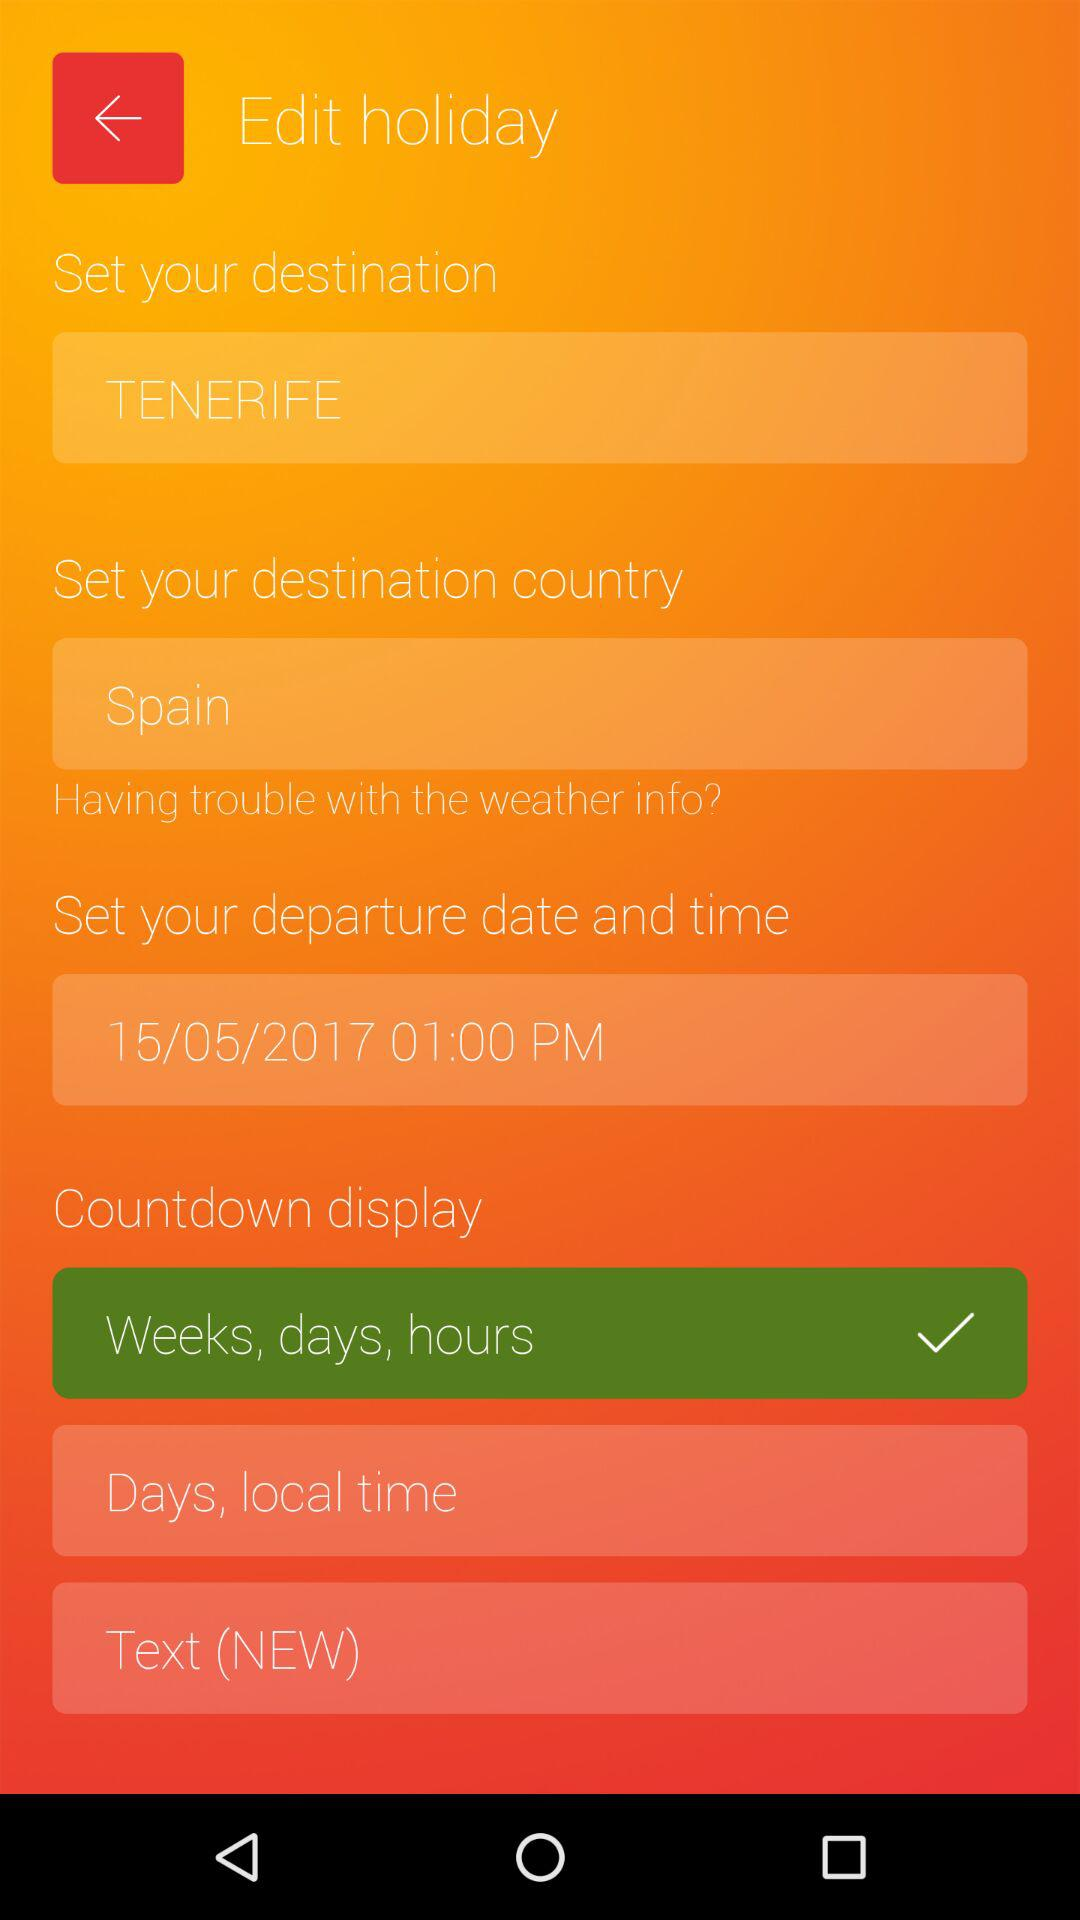What is the selected destination country? The selected destination country is Spain. 